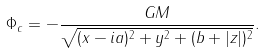Convert formula to latex. <formula><loc_0><loc_0><loc_500><loc_500>\Phi _ { c } = - \frac { G M } { \sqrt { ( x - i a ) ^ { 2 } + y ^ { 2 } + ( b + | z | ) ^ { 2 } } } .</formula> 